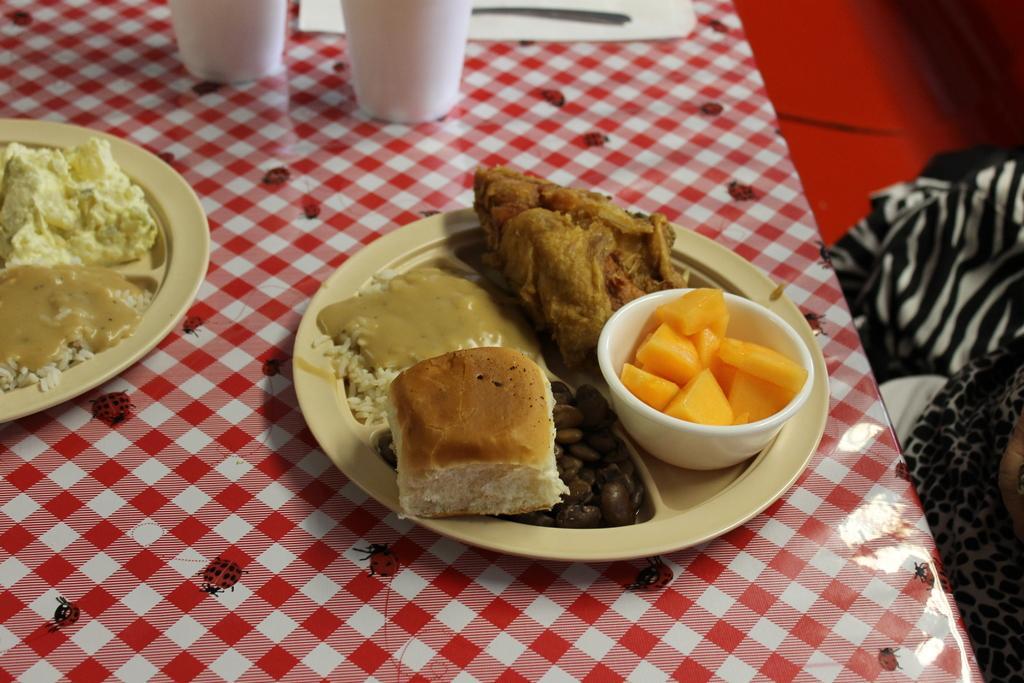Can you describe this image briefly? In this picture, we see two glasses, tray, spoon, two plates containing food and a bowl containing cut fruits are placed on the table. This table is covered with red color sheet. On the right side, we see a person in white and black dress is sitting on the chair. In the right top of the picture, we see a red color carpet. 